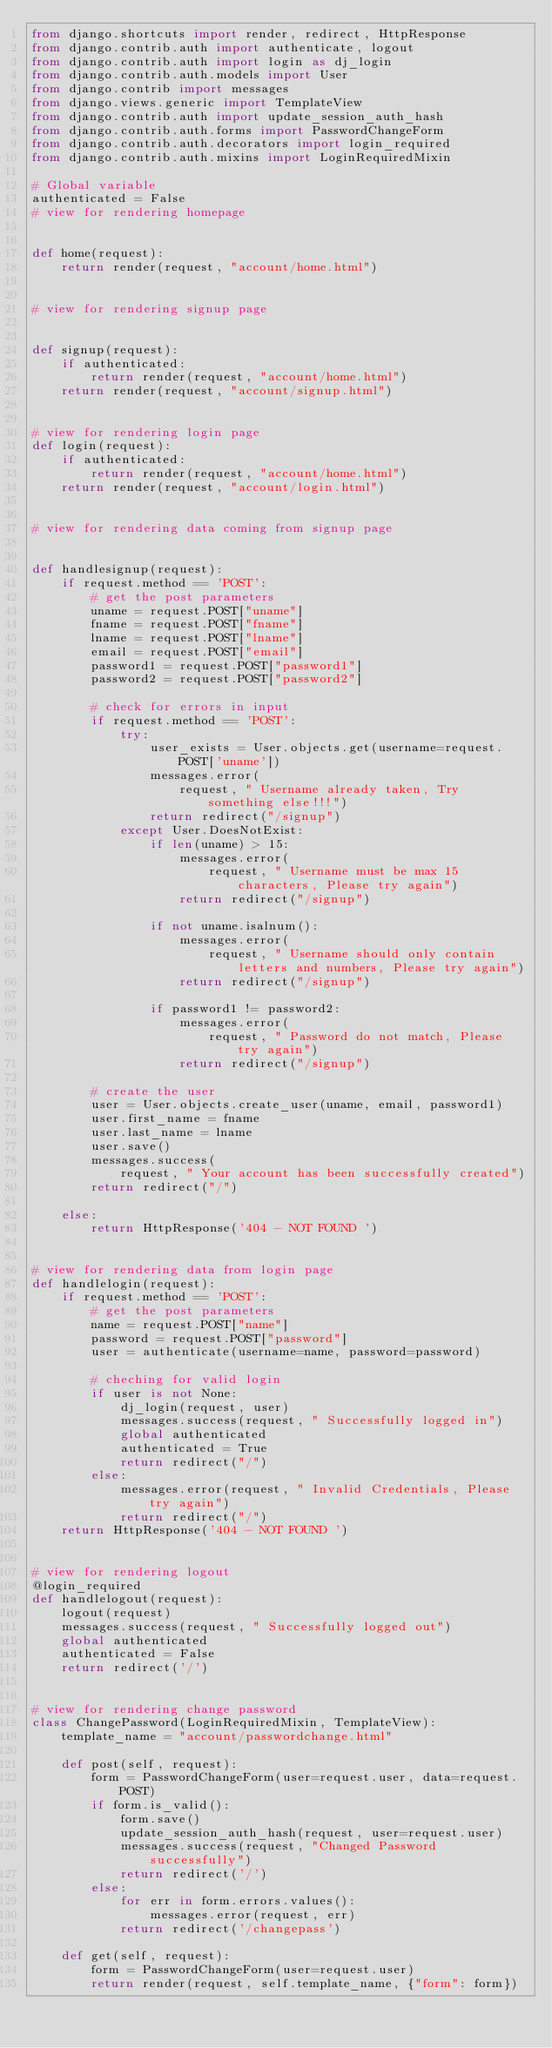Convert code to text. <code><loc_0><loc_0><loc_500><loc_500><_Python_>from django.shortcuts import render, redirect, HttpResponse
from django.contrib.auth import authenticate, logout
from django.contrib.auth import login as dj_login
from django.contrib.auth.models import User
from django.contrib import messages
from django.views.generic import TemplateView
from django.contrib.auth import update_session_auth_hash
from django.contrib.auth.forms import PasswordChangeForm
from django.contrib.auth.decorators import login_required
from django.contrib.auth.mixins import LoginRequiredMixin

# Global variable
authenticated = False
# view for rendering homepage


def home(request):
    return render(request, "account/home.html")


# view for rendering signup page


def signup(request):
    if authenticated:
        return render(request, "account/home.html")
    return render(request, "account/signup.html")


# view for rendering login page
def login(request):
    if authenticated:
        return render(request, "account/home.html")
    return render(request, "account/login.html")


# view for rendering data coming from signup page


def handlesignup(request):
    if request.method == 'POST':
        # get the post parameters
        uname = request.POST["uname"]
        fname = request.POST["fname"]
        lname = request.POST["lname"]
        email = request.POST["email"]
        password1 = request.POST["password1"]
        password2 = request.POST["password2"]

        # check for errors in input
        if request.method == 'POST':
            try:
                user_exists = User.objects.get(username=request.POST['uname'])
                messages.error(
                    request, " Username already taken, Try something else!!!")
                return redirect("/signup")
            except User.DoesNotExist:
                if len(uname) > 15:
                    messages.error(
                        request, " Username must be max 15 characters, Please try again")
                    return redirect("/signup")

                if not uname.isalnum():
                    messages.error(
                        request, " Username should only contain letters and numbers, Please try again")
                    return redirect("/signup")

                if password1 != password2:
                    messages.error(
                        request, " Password do not match, Please try again")
                    return redirect("/signup")

        # create the user
        user = User.objects.create_user(uname, email, password1)
        user.first_name = fname
        user.last_name = lname
        user.save()
        messages.success(
            request, " Your account has been successfully created")
        return redirect("/")

    else:
        return HttpResponse('404 - NOT FOUND ')


# view for rendering data from login page
def handlelogin(request):
    if request.method == 'POST':
        # get the post parameters
        name = request.POST["name"]
        password = request.POST["password"]
        user = authenticate(username=name, password=password)

        # cheching for valid login
        if user is not None:
            dj_login(request, user)
            messages.success(request, " Successfully logged in")
            global authenticated
            authenticated = True
            return redirect("/")
        else:
            messages.error(request, " Invalid Credentials, Please try again")
            return redirect("/")
    return HttpResponse('404 - NOT FOUND ')


# view for rendering logout
@login_required
def handlelogout(request):
    logout(request)
    messages.success(request, " Successfully logged out")
    global authenticated
    authenticated = False
    return redirect('/')


# view for rendering change password
class ChangePassword(LoginRequiredMixin, TemplateView):
    template_name = "account/passwordchange.html"

    def post(self, request):
        form = PasswordChangeForm(user=request.user, data=request.POST)
        if form.is_valid():
            form.save()
            update_session_auth_hash(request, user=request.user)
            messages.success(request, "Changed Password successfully")
            return redirect('/')
        else:
            for err in form.errors.values():
                messages.error(request, err)
            return redirect('/changepass')

    def get(self, request):
        form = PasswordChangeForm(user=request.user)
        return render(request, self.template_name, {"form": form})
</code> 